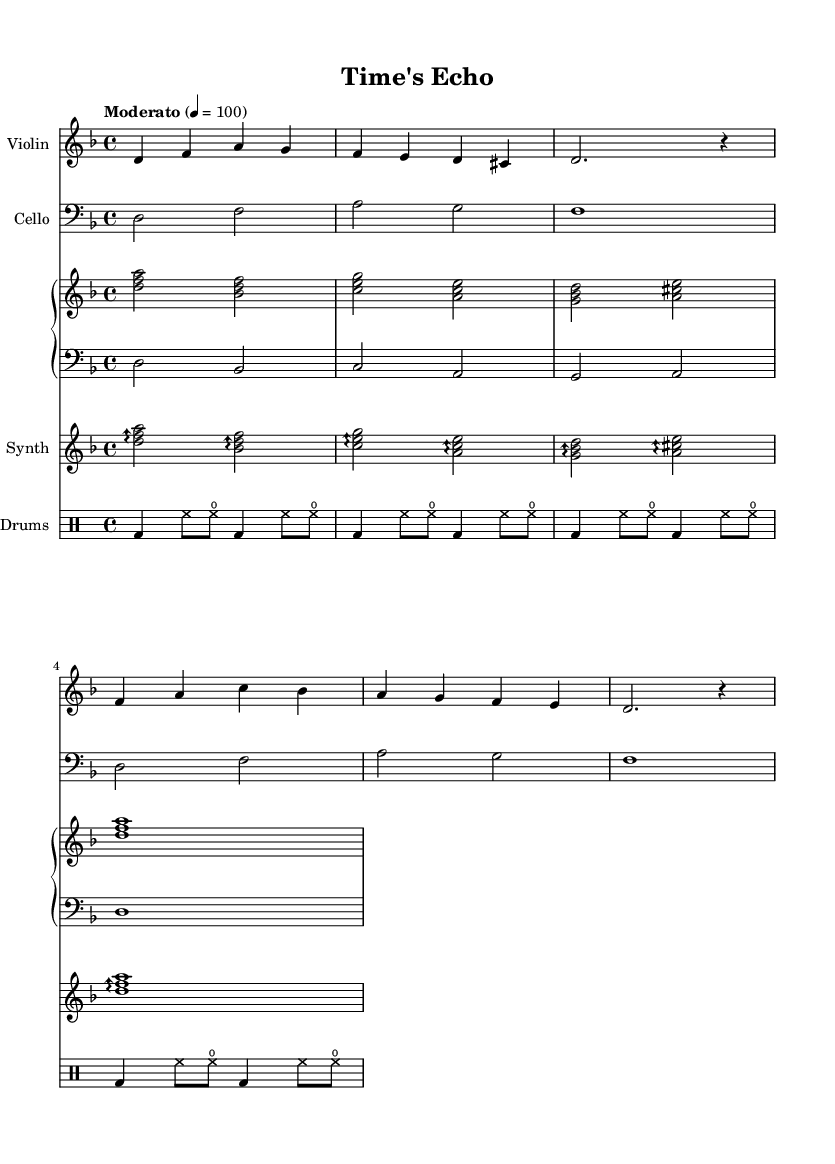What is the key signature of this music? The key signature is D minor, which consists of one flat (B flat). It can be identified by looking at the beginning of the score where the key signature is indicated.
Answer: D minor What is the time signature of this piece? The time signature is 4/4, meaning there are four beats per measure and a quarter note receives one beat. This can be found at the beginning of the score, right next to the key signature.
Answer: 4/4 What is the tempo marking for this music? The tempo marking indicates "Moderato," which implies a moderate speed. It is usually indicated at the beginning of the score with the tempo text and metronome marking adjacent to it.
Answer: Moderato How many measures are there in the violin section? There are four measures in the violin section, which can be counted by looking at the vertical lines (bar lines) in the violin staff. Each section of music between two bar lines represents one measure.
Answer: 4 Which instrument has the lowest range in this composition? The cello has the lowest range. This can be determined by noticing that the cello staff is in the bass clef, indicating lower notes compared to other instruments that are in treble clefs, such as violin or synth.
Answer: Cello What type of synth is specified in this piece? The synth is specified as "lead 2 (sawtooth)," which is indicated in the synth’s section. This specifies the sound that should be used for the synth part in the electronic-orchestral fusion.
Answer: Lead 2 (sawtooth) What instruments are used in this composition? The instruments used are Violin, Cello, Synth, and Drums. This information can be found at the beginning of each staff where the names of the instruments are displayed.
Answer: Violin, Cello, Synth, Drums 